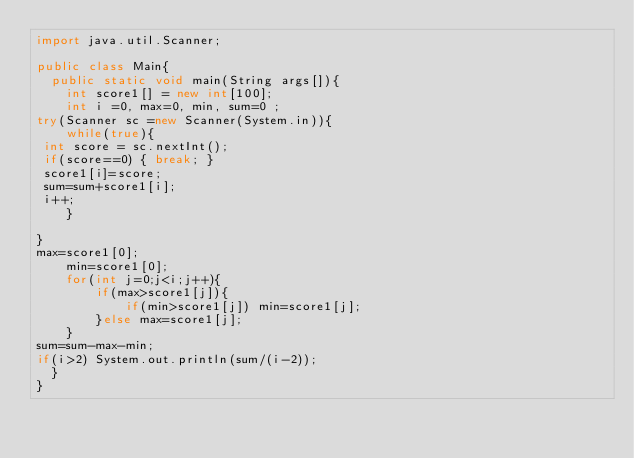<code> <loc_0><loc_0><loc_500><loc_500><_Java_>import java.util.Scanner;

public class Main{
  public static void main(String args[]){
    int score1[] = new int[100];
    int i =0, max=0, min, sum=0 ;
try(Scanner sc =new Scanner(System.in)){
    while(true){
 int score = sc.nextInt();
 if(score==0) { break; }
 score1[i]=score;
 sum=sum+score1[i];
 i++;
    }
   
}
max=score1[0];
    min=score1[0];
    for(int j=0;j<i;j++){
        if(max>score1[j]){
            if(min>score1[j]) min=score1[j];       
        }else max=score1[j];
    }
sum=sum-max-min;
if(i>2) System.out.println(sum/(i-2));
  }
}



</code> 